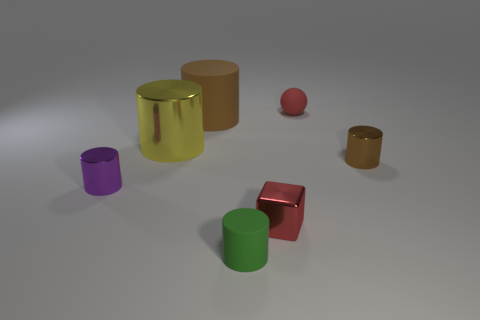Subtract all yellow metallic cylinders. How many cylinders are left? 4 Add 2 big yellow metallic cylinders. How many objects exist? 9 Subtract all yellow cylinders. How many cylinders are left? 4 Subtract 4 cylinders. How many cylinders are left? 1 Add 5 purple objects. How many purple objects exist? 6 Subtract 0 gray blocks. How many objects are left? 7 Subtract all balls. How many objects are left? 6 Subtract all purple cylinders. Subtract all red cubes. How many cylinders are left? 4 Subtract all purple cubes. How many yellow cylinders are left? 1 Subtract all tiny red objects. Subtract all big cyan cylinders. How many objects are left? 5 